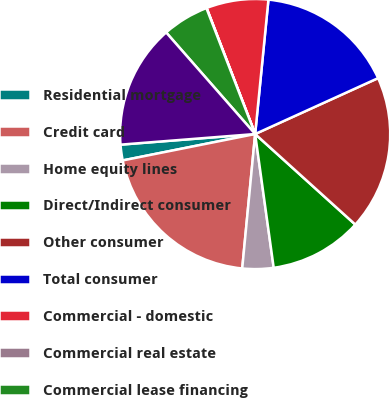Convert chart to OTSL. <chart><loc_0><loc_0><loc_500><loc_500><pie_chart><fcel>Residential mortgage<fcel>Credit card<fcel>Home equity lines<fcel>Direct/Indirect consumer<fcel>Other consumer<fcel>Total consumer<fcel>Commercial - domestic<fcel>Commercial real estate<fcel>Commercial lease financing<fcel>Commercial - foreign<nl><fcel>1.88%<fcel>20.34%<fcel>3.72%<fcel>11.11%<fcel>18.49%<fcel>16.64%<fcel>7.42%<fcel>0.03%<fcel>5.57%<fcel>14.8%<nl></chart> 